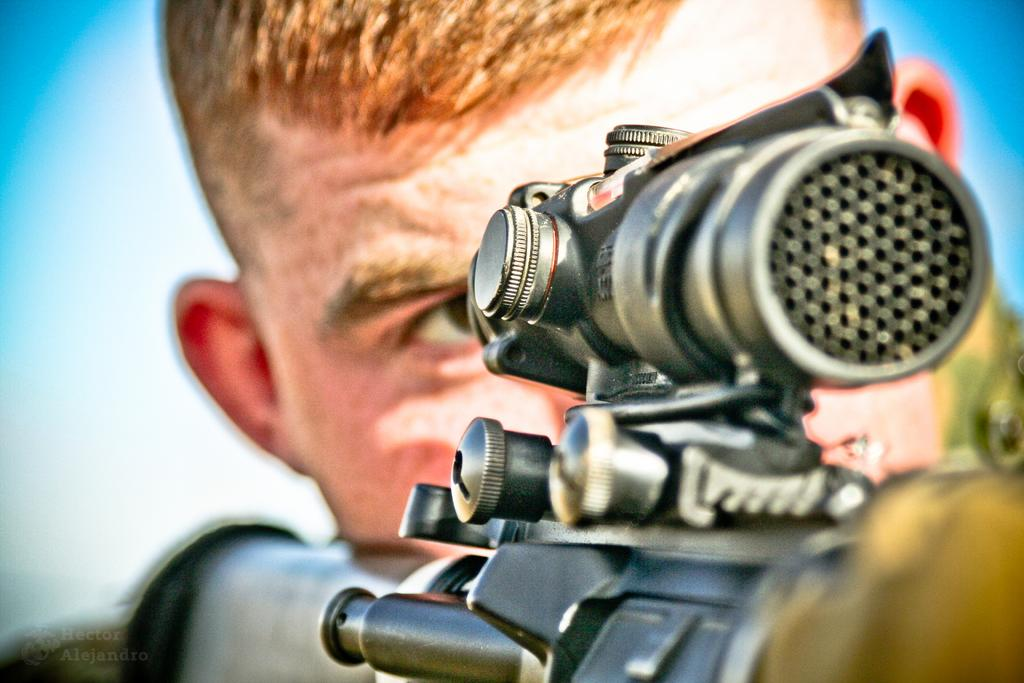What is the main subject of the image? There is a person in the image. What is the person holding in the image? The person is holding a gun. What can be seen in the background of the image? There is a sky visible in the background of the image. What type of flowers can be seen growing around the person in the image? There are no flowers present in the image. How does the person twist the gun in the image? The person is not twisting the gun in the image; they are simply holding it. 